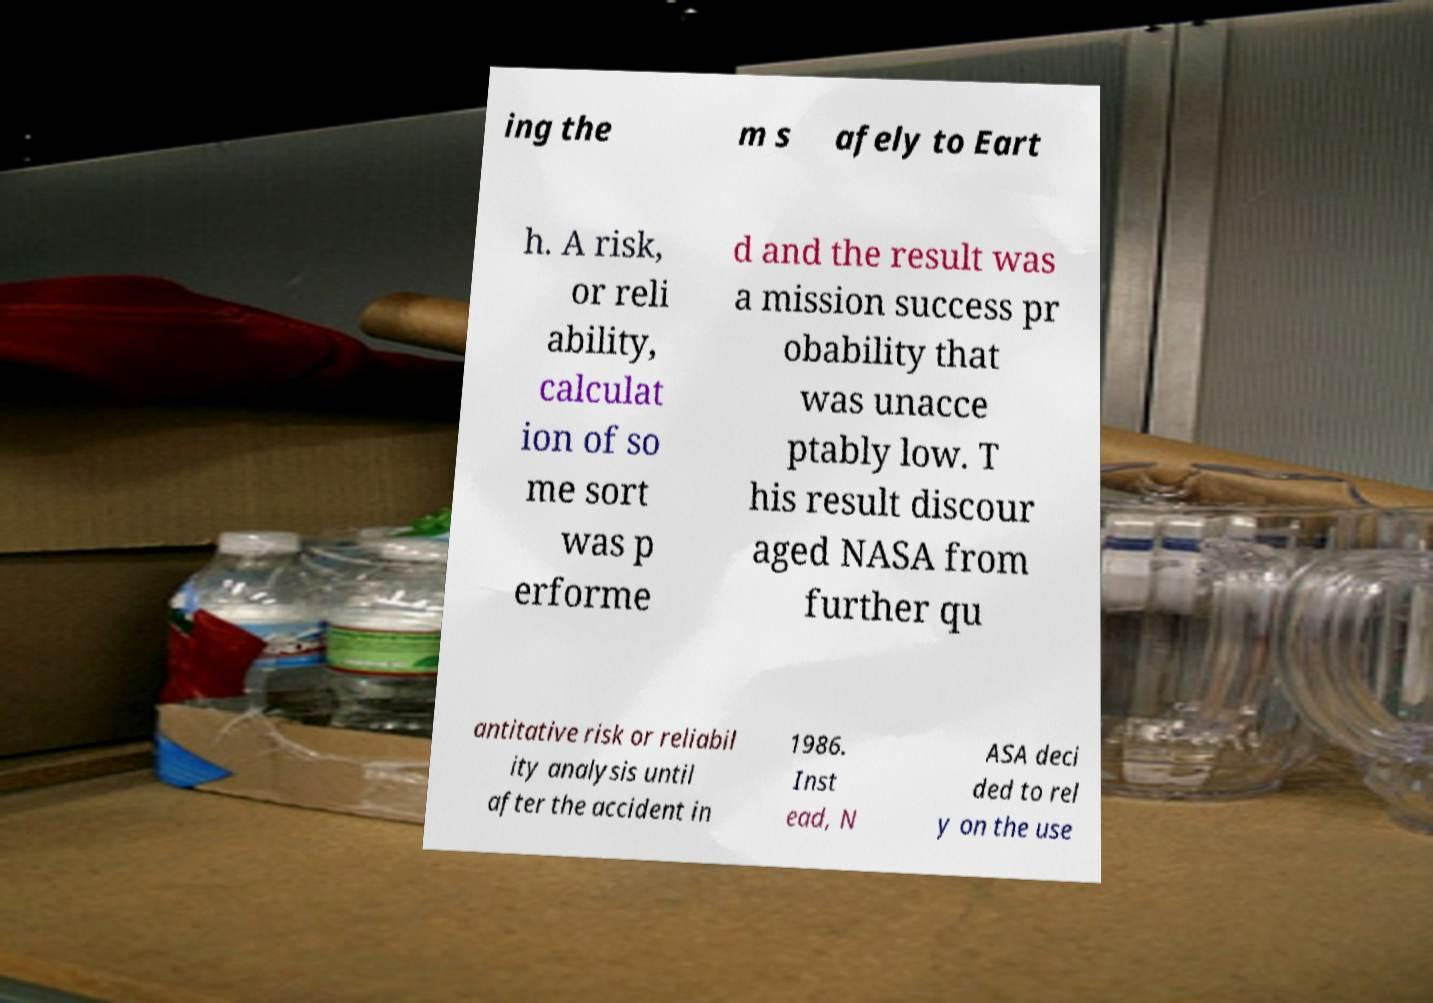Can you read and provide the text displayed in the image?This photo seems to have some interesting text. Can you extract and type it out for me? ing the m s afely to Eart h. A risk, or reli ability, calculat ion of so me sort was p erforme d and the result was a mission success pr obability that was unacce ptably low. T his result discour aged NASA from further qu antitative risk or reliabil ity analysis until after the accident in 1986. Inst ead, N ASA deci ded to rel y on the use 